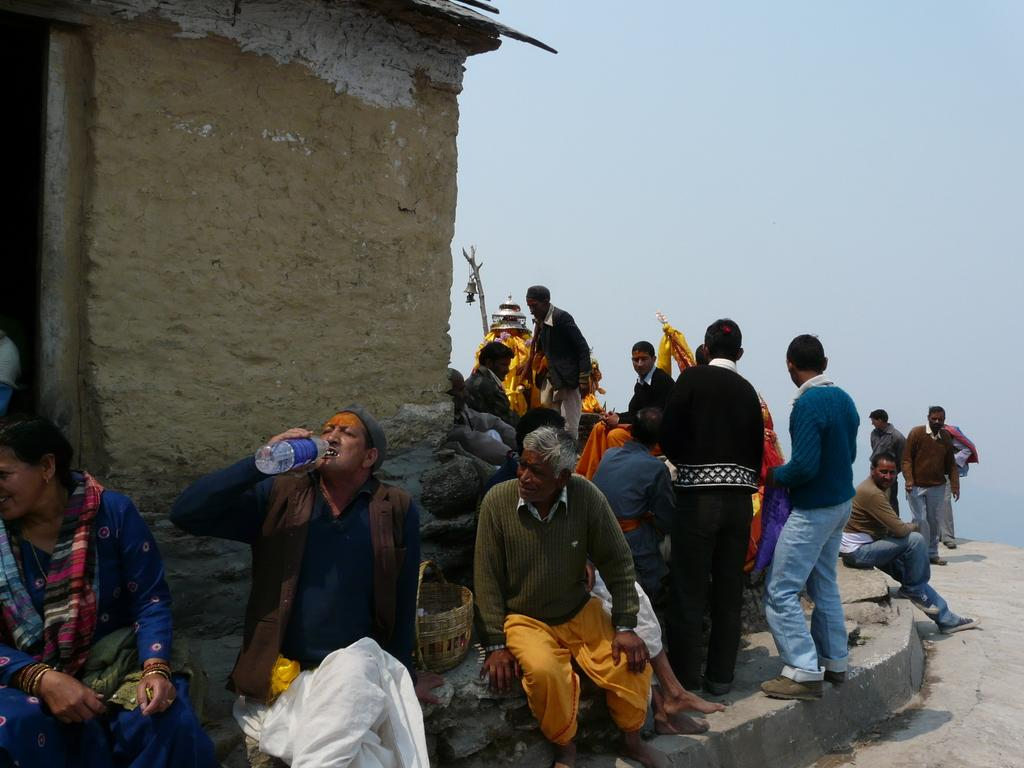What are the people in the image doing? There are people sitting and standing in the image. What can be seen behind the people in the image? There is a wall visible in the image. What is visible at the top of the image? The sky is visible at the top of the image. How many fingers can be seen on the birthday cake in the image? There is no birthday cake or fingers present in the image. What type of elbow is visible in the image? There are no elbows visible in the image. 